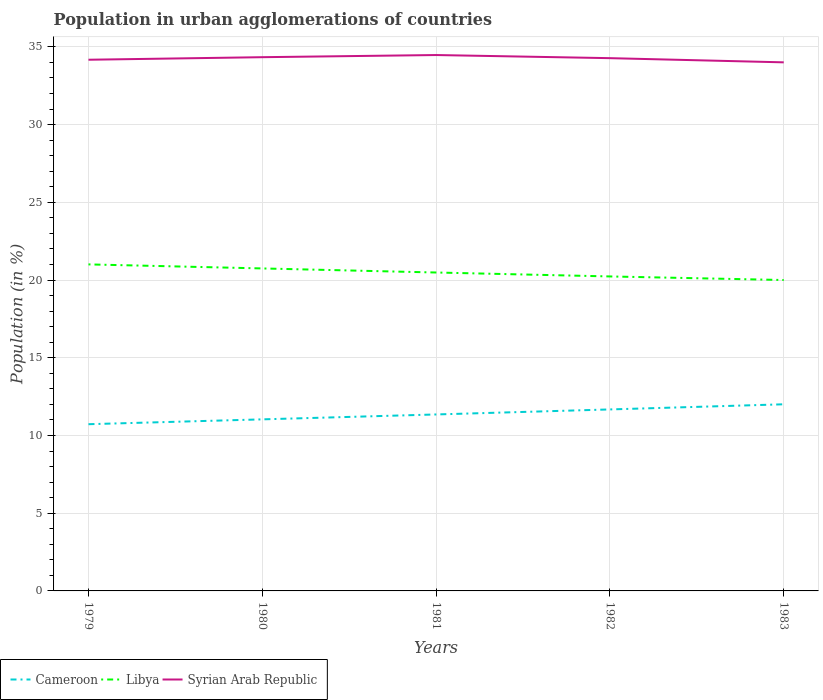Does the line corresponding to Libya intersect with the line corresponding to Cameroon?
Provide a succinct answer. No. Is the number of lines equal to the number of legend labels?
Provide a short and direct response. Yes. Across all years, what is the maximum percentage of population in urban agglomerations in Cameroon?
Offer a very short reply. 10.73. In which year was the percentage of population in urban agglomerations in Syrian Arab Republic maximum?
Your answer should be very brief. 1983. What is the total percentage of population in urban agglomerations in Libya in the graph?
Provide a succinct answer. 0.75. What is the difference between the highest and the second highest percentage of population in urban agglomerations in Libya?
Your answer should be very brief. 1.01. How many lines are there?
Make the answer very short. 3. Are the values on the major ticks of Y-axis written in scientific E-notation?
Give a very brief answer. No. Where does the legend appear in the graph?
Make the answer very short. Bottom left. How many legend labels are there?
Provide a short and direct response. 3. How are the legend labels stacked?
Ensure brevity in your answer.  Horizontal. What is the title of the graph?
Your answer should be compact. Population in urban agglomerations of countries. What is the Population (in %) of Cameroon in 1979?
Your answer should be compact. 10.73. What is the Population (in %) in Libya in 1979?
Keep it short and to the point. 21.01. What is the Population (in %) in Syrian Arab Republic in 1979?
Offer a very short reply. 34.17. What is the Population (in %) of Cameroon in 1980?
Provide a succinct answer. 11.04. What is the Population (in %) of Libya in 1980?
Give a very brief answer. 20.75. What is the Population (in %) in Syrian Arab Republic in 1980?
Give a very brief answer. 34.34. What is the Population (in %) of Cameroon in 1981?
Your response must be concise. 11.35. What is the Population (in %) of Libya in 1981?
Provide a succinct answer. 20.48. What is the Population (in %) in Syrian Arab Republic in 1981?
Give a very brief answer. 34.48. What is the Population (in %) of Cameroon in 1982?
Give a very brief answer. 11.68. What is the Population (in %) of Libya in 1982?
Keep it short and to the point. 20.23. What is the Population (in %) in Syrian Arab Republic in 1982?
Keep it short and to the point. 34.27. What is the Population (in %) in Cameroon in 1983?
Give a very brief answer. 12.01. What is the Population (in %) in Libya in 1983?
Keep it short and to the point. 20. What is the Population (in %) of Syrian Arab Republic in 1983?
Provide a succinct answer. 34.01. Across all years, what is the maximum Population (in %) of Cameroon?
Ensure brevity in your answer.  12.01. Across all years, what is the maximum Population (in %) in Libya?
Your answer should be very brief. 21.01. Across all years, what is the maximum Population (in %) in Syrian Arab Republic?
Provide a short and direct response. 34.48. Across all years, what is the minimum Population (in %) in Cameroon?
Keep it short and to the point. 10.73. Across all years, what is the minimum Population (in %) of Libya?
Provide a succinct answer. 20. Across all years, what is the minimum Population (in %) of Syrian Arab Republic?
Ensure brevity in your answer.  34.01. What is the total Population (in %) in Cameroon in the graph?
Your response must be concise. 56.8. What is the total Population (in %) in Libya in the graph?
Ensure brevity in your answer.  102.47. What is the total Population (in %) of Syrian Arab Republic in the graph?
Make the answer very short. 171.27. What is the difference between the Population (in %) of Cameroon in 1979 and that in 1980?
Provide a succinct answer. -0.31. What is the difference between the Population (in %) of Libya in 1979 and that in 1980?
Your response must be concise. 0.26. What is the difference between the Population (in %) of Syrian Arab Republic in 1979 and that in 1980?
Provide a succinct answer. -0.16. What is the difference between the Population (in %) in Cameroon in 1979 and that in 1981?
Offer a terse response. -0.63. What is the difference between the Population (in %) of Libya in 1979 and that in 1981?
Your answer should be compact. 0.52. What is the difference between the Population (in %) in Syrian Arab Republic in 1979 and that in 1981?
Your answer should be very brief. -0.3. What is the difference between the Population (in %) of Cameroon in 1979 and that in 1982?
Provide a short and direct response. -0.95. What is the difference between the Population (in %) in Libya in 1979 and that in 1982?
Keep it short and to the point. 0.78. What is the difference between the Population (in %) of Syrian Arab Republic in 1979 and that in 1982?
Offer a terse response. -0.1. What is the difference between the Population (in %) of Cameroon in 1979 and that in 1983?
Ensure brevity in your answer.  -1.28. What is the difference between the Population (in %) of Syrian Arab Republic in 1979 and that in 1983?
Provide a short and direct response. 0.17. What is the difference between the Population (in %) of Cameroon in 1980 and that in 1981?
Your response must be concise. -0.32. What is the difference between the Population (in %) in Libya in 1980 and that in 1981?
Your answer should be very brief. 0.26. What is the difference between the Population (in %) of Syrian Arab Republic in 1980 and that in 1981?
Offer a very short reply. -0.14. What is the difference between the Population (in %) in Cameroon in 1980 and that in 1982?
Make the answer very short. -0.64. What is the difference between the Population (in %) in Libya in 1980 and that in 1982?
Ensure brevity in your answer.  0.52. What is the difference between the Population (in %) of Syrian Arab Republic in 1980 and that in 1982?
Provide a succinct answer. 0.06. What is the difference between the Population (in %) in Cameroon in 1980 and that in 1983?
Your answer should be very brief. -0.97. What is the difference between the Population (in %) in Libya in 1980 and that in 1983?
Give a very brief answer. 0.75. What is the difference between the Population (in %) of Syrian Arab Republic in 1980 and that in 1983?
Ensure brevity in your answer.  0.33. What is the difference between the Population (in %) of Cameroon in 1981 and that in 1982?
Offer a very short reply. -0.32. What is the difference between the Population (in %) in Libya in 1981 and that in 1982?
Provide a succinct answer. 0.25. What is the difference between the Population (in %) of Syrian Arab Republic in 1981 and that in 1982?
Make the answer very short. 0.2. What is the difference between the Population (in %) in Cameroon in 1981 and that in 1983?
Provide a succinct answer. -0.65. What is the difference between the Population (in %) of Libya in 1981 and that in 1983?
Give a very brief answer. 0.48. What is the difference between the Population (in %) of Syrian Arab Republic in 1981 and that in 1983?
Ensure brevity in your answer.  0.47. What is the difference between the Population (in %) of Cameroon in 1982 and that in 1983?
Provide a succinct answer. -0.33. What is the difference between the Population (in %) of Libya in 1982 and that in 1983?
Offer a very short reply. 0.23. What is the difference between the Population (in %) in Syrian Arab Republic in 1982 and that in 1983?
Offer a very short reply. 0.27. What is the difference between the Population (in %) in Cameroon in 1979 and the Population (in %) in Libya in 1980?
Offer a very short reply. -10.02. What is the difference between the Population (in %) in Cameroon in 1979 and the Population (in %) in Syrian Arab Republic in 1980?
Offer a terse response. -23.61. What is the difference between the Population (in %) in Libya in 1979 and the Population (in %) in Syrian Arab Republic in 1980?
Provide a succinct answer. -13.33. What is the difference between the Population (in %) of Cameroon in 1979 and the Population (in %) of Libya in 1981?
Offer a terse response. -9.76. What is the difference between the Population (in %) of Cameroon in 1979 and the Population (in %) of Syrian Arab Republic in 1981?
Your answer should be compact. -23.75. What is the difference between the Population (in %) of Libya in 1979 and the Population (in %) of Syrian Arab Republic in 1981?
Ensure brevity in your answer.  -13.47. What is the difference between the Population (in %) of Cameroon in 1979 and the Population (in %) of Libya in 1982?
Offer a terse response. -9.51. What is the difference between the Population (in %) in Cameroon in 1979 and the Population (in %) in Syrian Arab Republic in 1982?
Give a very brief answer. -23.55. What is the difference between the Population (in %) in Libya in 1979 and the Population (in %) in Syrian Arab Republic in 1982?
Provide a succinct answer. -13.27. What is the difference between the Population (in %) in Cameroon in 1979 and the Population (in %) in Libya in 1983?
Offer a very short reply. -9.28. What is the difference between the Population (in %) in Cameroon in 1979 and the Population (in %) in Syrian Arab Republic in 1983?
Your response must be concise. -23.28. What is the difference between the Population (in %) in Libya in 1979 and the Population (in %) in Syrian Arab Republic in 1983?
Offer a terse response. -13. What is the difference between the Population (in %) in Cameroon in 1980 and the Population (in %) in Libya in 1981?
Your response must be concise. -9.45. What is the difference between the Population (in %) of Cameroon in 1980 and the Population (in %) of Syrian Arab Republic in 1981?
Provide a succinct answer. -23.44. What is the difference between the Population (in %) of Libya in 1980 and the Population (in %) of Syrian Arab Republic in 1981?
Make the answer very short. -13.73. What is the difference between the Population (in %) of Cameroon in 1980 and the Population (in %) of Libya in 1982?
Provide a succinct answer. -9.19. What is the difference between the Population (in %) of Cameroon in 1980 and the Population (in %) of Syrian Arab Republic in 1982?
Make the answer very short. -23.24. What is the difference between the Population (in %) of Libya in 1980 and the Population (in %) of Syrian Arab Republic in 1982?
Your answer should be very brief. -13.53. What is the difference between the Population (in %) in Cameroon in 1980 and the Population (in %) in Libya in 1983?
Offer a very short reply. -8.96. What is the difference between the Population (in %) of Cameroon in 1980 and the Population (in %) of Syrian Arab Republic in 1983?
Your answer should be compact. -22.97. What is the difference between the Population (in %) of Libya in 1980 and the Population (in %) of Syrian Arab Republic in 1983?
Keep it short and to the point. -13.26. What is the difference between the Population (in %) of Cameroon in 1981 and the Population (in %) of Libya in 1982?
Your answer should be very brief. -8.88. What is the difference between the Population (in %) in Cameroon in 1981 and the Population (in %) in Syrian Arab Republic in 1982?
Your answer should be very brief. -22.92. What is the difference between the Population (in %) in Libya in 1981 and the Population (in %) in Syrian Arab Republic in 1982?
Your answer should be compact. -13.79. What is the difference between the Population (in %) of Cameroon in 1981 and the Population (in %) of Libya in 1983?
Your answer should be very brief. -8.65. What is the difference between the Population (in %) of Cameroon in 1981 and the Population (in %) of Syrian Arab Republic in 1983?
Your answer should be very brief. -22.65. What is the difference between the Population (in %) of Libya in 1981 and the Population (in %) of Syrian Arab Republic in 1983?
Your response must be concise. -13.52. What is the difference between the Population (in %) in Cameroon in 1982 and the Population (in %) in Libya in 1983?
Offer a terse response. -8.33. What is the difference between the Population (in %) of Cameroon in 1982 and the Population (in %) of Syrian Arab Republic in 1983?
Your answer should be compact. -22.33. What is the difference between the Population (in %) of Libya in 1982 and the Population (in %) of Syrian Arab Republic in 1983?
Offer a very short reply. -13.77. What is the average Population (in %) of Cameroon per year?
Your answer should be compact. 11.36. What is the average Population (in %) in Libya per year?
Make the answer very short. 20.49. What is the average Population (in %) of Syrian Arab Republic per year?
Give a very brief answer. 34.25. In the year 1979, what is the difference between the Population (in %) of Cameroon and Population (in %) of Libya?
Offer a very short reply. -10.28. In the year 1979, what is the difference between the Population (in %) in Cameroon and Population (in %) in Syrian Arab Republic?
Your answer should be very brief. -23.45. In the year 1979, what is the difference between the Population (in %) of Libya and Population (in %) of Syrian Arab Republic?
Offer a very short reply. -13.17. In the year 1980, what is the difference between the Population (in %) in Cameroon and Population (in %) in Libya?
Provide a short and direct response. -9.71. In the year 1980, what is the difference between the Population (in %) in Cameroon and Population (in %) in Syrian Arab Republic?
Give a very brief answer. -23.3. In the year 1980, what is the difference between the Population (in %) in Libya and Population (in %) in Syrian Arab Republic?
Make the answer very short. -13.59. In the year 1981, what is the difference between the Population (in %) of Cameroon and Population (in %) of Libya?
Your answer should be very brief. -9.13. In the year 1981, what is the difference between the Population (in %) in Cameroon and Population (in %) in Syrian Arab Republic?
Your answer should be very brief. -23.12. In the year 1981, what is the difference between the Population (in %) in Libya and Population (in %) in Syrian Arab Republic?
Offer a terse response. -13.99. In the year 1982, what is the difference between the Population (in %) in Cameroon and Population (in %) in Libya?
Your answer should be very brief. -8.56. In the year 1982, what is the difference between the Population (in %) of Cameroon and Population (in %) of Syrian Arab Republic?
Your response must be concise. -22.6. In the year 1982, what is the difference between the Population (in %) of Libya and Population (in %) of Syrian Arab Republic?
Make the answer very short. -14.04. In the year 1983, what is the difference between the Population (in %) of Cameroon and Population (in %) of Libya?
Provide a succinct answer. -7.99. In the year 1983, what is the difference between the Population (in %) in Cameroon and Population (in %) in Syrian Arab Republic?
Provide a short and direct response. -22. In the year 1983, what is the difference between the Population (in %) of Libya and Population (in %) of Syrian Arab Republic?
Keep it short and to the point. -14. What is the ratio of the Population (in %) in Cameroon in 1979 to that in 1980?
Ensure brevity in your answer.  0.97. What is the ratio of the Population (in %) of Libya in 1979 to that in 1980?
Offer a very short reply. 1.01. What is the ratio of the Population (in %) in Syrian Arab Republic in 1979 to that in 1980?
Offer a terse response. 1. What is the ratio of the Population (in %) in Cameroon in 1979 to that in 1981?
Your answer should be compact. 0.94. What is the ratio of the Population (in %) of Libya in 1979 to that in 1981?
Provide a short and direct response. 1.03. What is the ratio of the Population (in %) of Cameroon in 1979 to that in 1982?
Make the answer very short. 0.92. What is the ratio of the Population (in %) of Libya in 1979 to that in 1982?
Keep it short and to the point. 1.04. What is the ratio of the Population (in %) of Syrian Arab Republic in 1979 to that in 1982?
Provide a short and direct response. 1. What is the ratio of the Population (in %) in Cameroon in 1979 to that in 1983?
Your answer should be compact. 0.89. What is the ratio of the Population (in %) of Libya in 1979 to that in 1983?
Give a very brief answer. 1.05. What is the ratio of the Population (in %) of Syrian Arab Republic in 1979 to that in 1983?
Your answer should be compact. 1. What is the ratio of the Population (in %) of Cameroon in 1980 to that in 1981?
Offer a terse response. 0.97. What is the ratio of the Population (in %) in Libya in 1980 to that in 1981?
Ensure brevity in your answer.  1.01. What is the ratio of the Population (in %) of Syrian Arab Republic in 1980 to that in 1981?
Keep it short and to the point. 1. What is the ratio of the Population (in %) of Cameroon in 1980 to that in 1982?
Provide a short and direct response. 0.95. What is the ratio of the Population (in %) in Libya in 1980 to that in 1982?
Offer a terse response. 1.03. What is the ratio of the Population (in %) in Syrian Arab Republic in 1980 to that in 1982?
Your response must be concise. 1. What is the ratio of the Population (in %) of Cameroon in 1980 to that in 1983?
Your response must be concise. 0.92. What is the ratio of the Population (in %) in Libya in 1980 to that in 1983?
Give a very brief answer. 1.04. What is the ratio of the Population (in %) of Syrian Arab Republic in 1980 to that in 1983?
Provide a short and direct response. 1.01. What is the ratio of the Population (in %) in Cameroon in 1981 to that in 1982?
Offer a terse response. 0.97. What is the ratio of the Population (in %) in Libya in 1981 to that in 1982?
Keep it short and to the point. 1.01. What is the ratio of the Population (in %) of Syrian Arab Republic in 1981 to that in 1982?
Your response must be concise. 1.01. What is the ratio of the Population (in %) of Cameroon in 1981 to that in 1983?
Give a very brief answer. 0.95. What is the ratio of the Population (in %) of Libya in 1981 to that in 1983?
Your answer should be compact. 1.02. What is the ratio of the Population (in %) of Syrian Arab Republic in 1981 to that in 1983?
Your response must be concise. 1.01. What is the ratio of the Population (in %) in Cameroon in 1982 to that in 1983?
Your response must be concise. 0.97. What is the ratio of the Population (in %) in Libya in 1982 to that in 1983?
Provide a short and direct response. 1.01. What is the ratio of the Population (in %) in Syrian Arab Republic in 1982 to that in 1983?
Offer a terse response. 1.01. What is the difference between the highest and the second highest Population (in %) in Cameroon?
Make the answer very short. 0.33. What is the difference between the highest and the second highest Population (in %) of Libya?
Give a very brief answer. 0.26. What is the difference between the highest and the second highest Population (in %) in Syrian Arab Republic?
Your response must be concise. 0.14. What is the difference between the highest and the lowest Population (in %) in Cameroon?
Offer a very short reply. 1.28. What is the difference between the highest and the lowest Population (in %) of Libya?
Give a very brief answer. 1.01. What is the difference between the highest and the lowest Population (in %) of Syrian Arab Republic?
Offer a terse response. 0.47. 